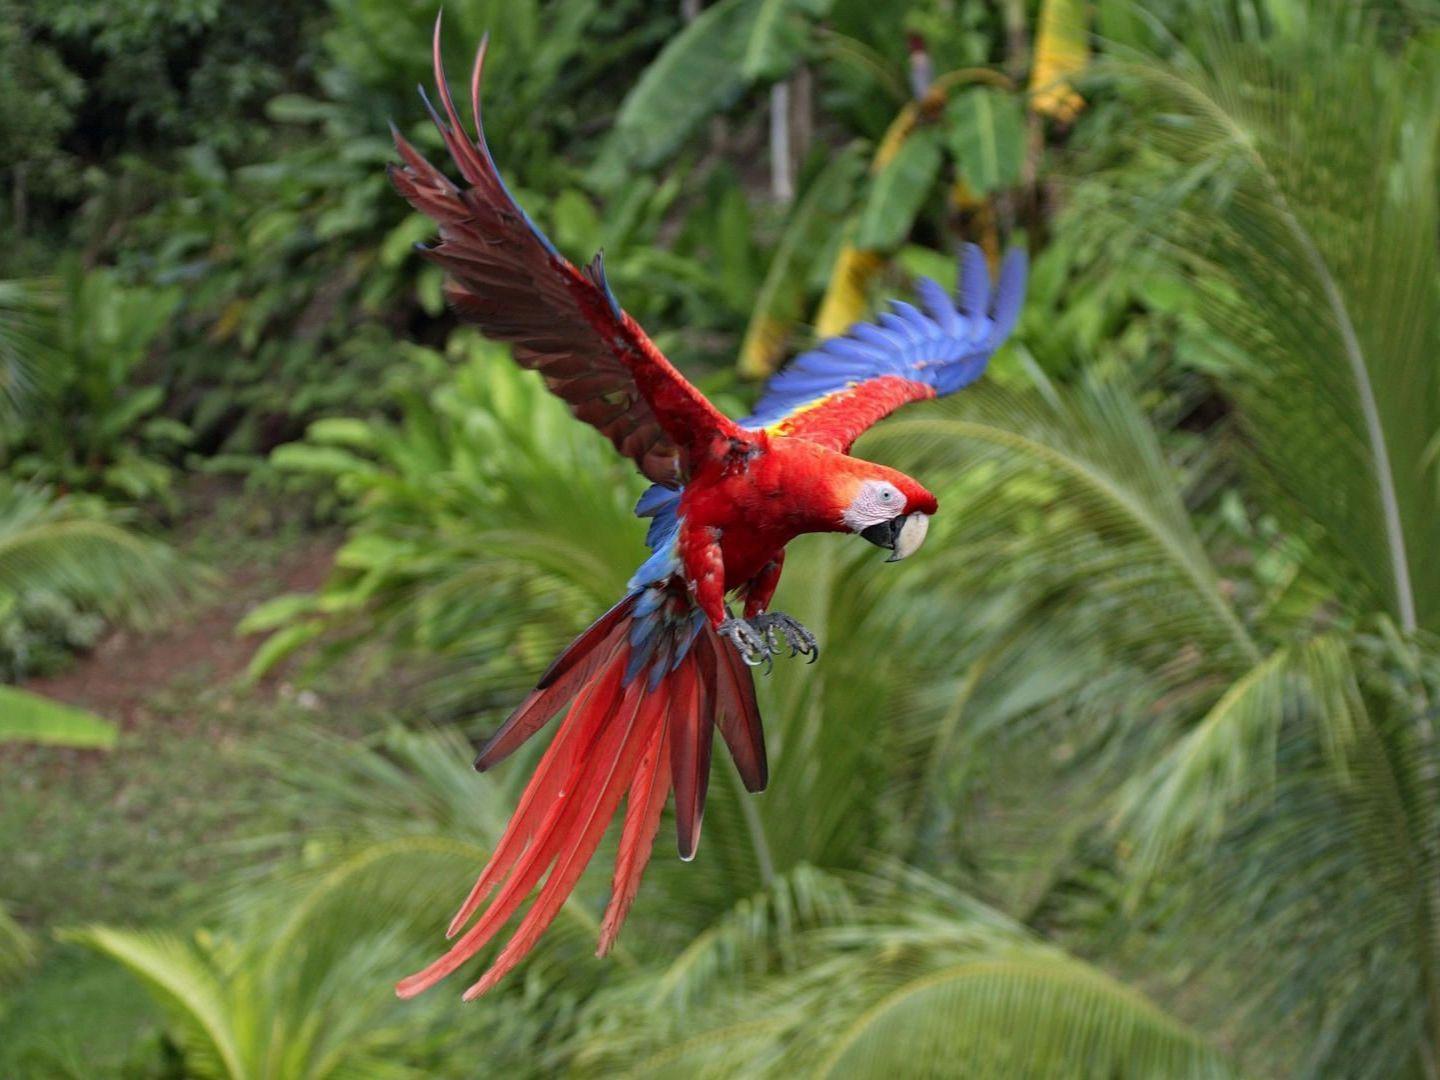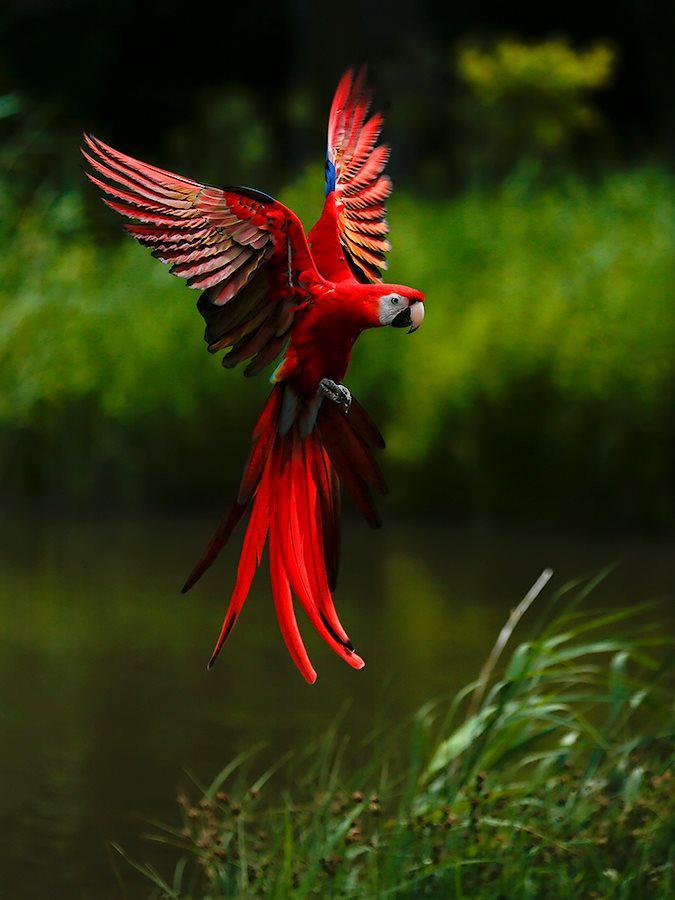The first image is the image on the left, the second image is the image on the right. For the images displayed, is the sentence "The bird in one of the images is flying to the left." factually correct? Answer yes or no. No. 